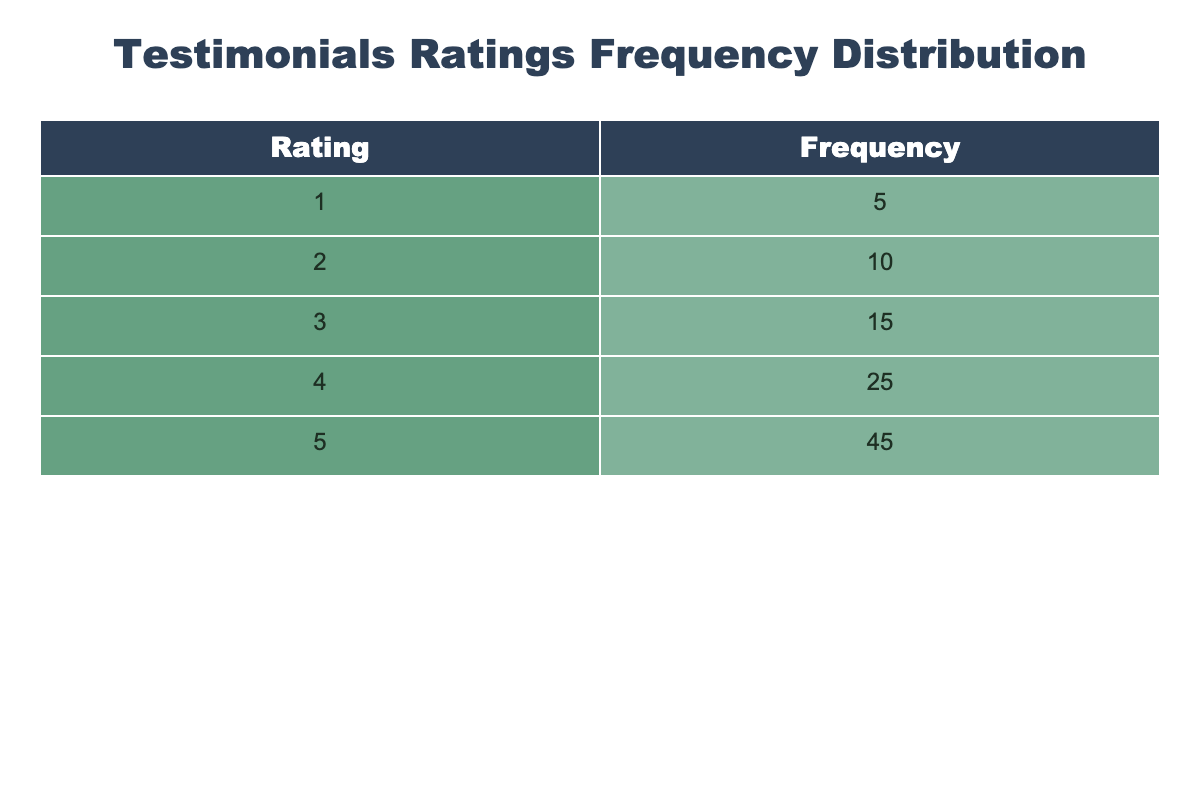What is the highest frequency of ratings in the table? The highest frequency corresponds to the rating of 5, which has a frequency count of 45. By checking the frequency column, it is evident that no other rating has a higher count than this.
Answer: 45 How many users rated the devices with a score of 3? According to the table, the frequency for a rating of 3 is clearly stated as 15. This means that 15 users gave a rating of 3.
Answer: 15 What are the total number of ratings given by users? To find the total number of ratings, we need to sum the frequencies for all ratings: 5 + 10 + 15 + 25 + 45 = 100. Therefore, the total ratings provided by users are 100.
Answer: 100 Is the number of users who rated the devices with a score of 1 less than those who rated with a score of 4? The frequency of ratings for 1 is 5 and for 4 it is 25. Since 5 is less than 25, the statement is true.
Answer: Yes What is the average rating given by users? To calculate the average rating, we first compute the weighted sum of the ratings: (1*5 + 2*10 + 3*15 + 4*25 + 5*45) = 1*5 + 20 + 45 + 100 + 225 = 395. Then, we divide this sum by the total number of ratings (100): 395/100 = 3.95. Thus, the average rating is 3.95.
Answer: 3.95 What is the difference in frequency between the highest and lowest rating? The highest frequency is 45 (for a rating of 5) and the lowest is 5 (for a rating of 1). Therefore, the difference in frequency is 45 - 5 = 40.
Answer: 40 How many ratings are equal to or above 4? Ratings equal to or above 4 include those for ratings of 4 and 5. The frequency for rating 4 is 25, and for rating 5 is 45. Summing those gives: 25 + 45 = 70. Therefore, 70 ratings are equal to or above 4.
Answer: 70 What percentage of users gave a rating of 2? The frequency for a rating of 2 is 10. To find the percentage, we divide the frequency by the total number of ratings and multiply by 100: (10 / 100) * 100 = 10%. Thus, 10% of users gave a rating of 2.
Answer: 10% 